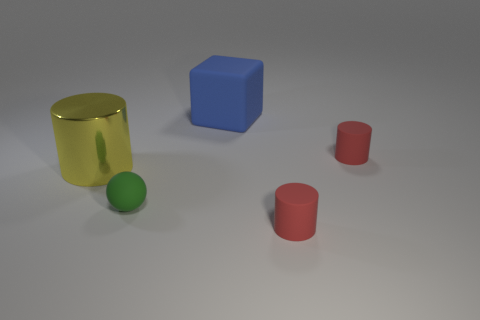Do the red rubber object that is in front of the large metal cylinder and the blue matte block behind the tiny green rubber ball have the same size?
Ensure brevity in your answer.  No. There is a thing that is behind the large yellow thing and in front of the large blue matte object; what material is it?
Make the answer very short. Rubber. What number of other things are there of the same size as the green matte ball?
Your answer should be compact. 2. What is the material of the tiny thing left of the large blue object?
Offer a very short reply. Rubber. How many other objects are there of the same shape as the metallic object?
Your answer should be very brief. 2. There is a rubber thing that is to the left of the blue matte thing; what is its color?
Your answer should be compact. Green. Is the blue cube the same size as the green sphere?
Offer a terse response. No. What is the small red object to the left of the small cylinder behind the large yellow metal cylinder made of?
Your response must be concise. Rubber. How many matte blocks are the same color as the tiny sphere?
Keep it short and to the point. 0. Are there any other things that are the same material as the yellow cylinder?
Ensure brevity in your answer.  No. 